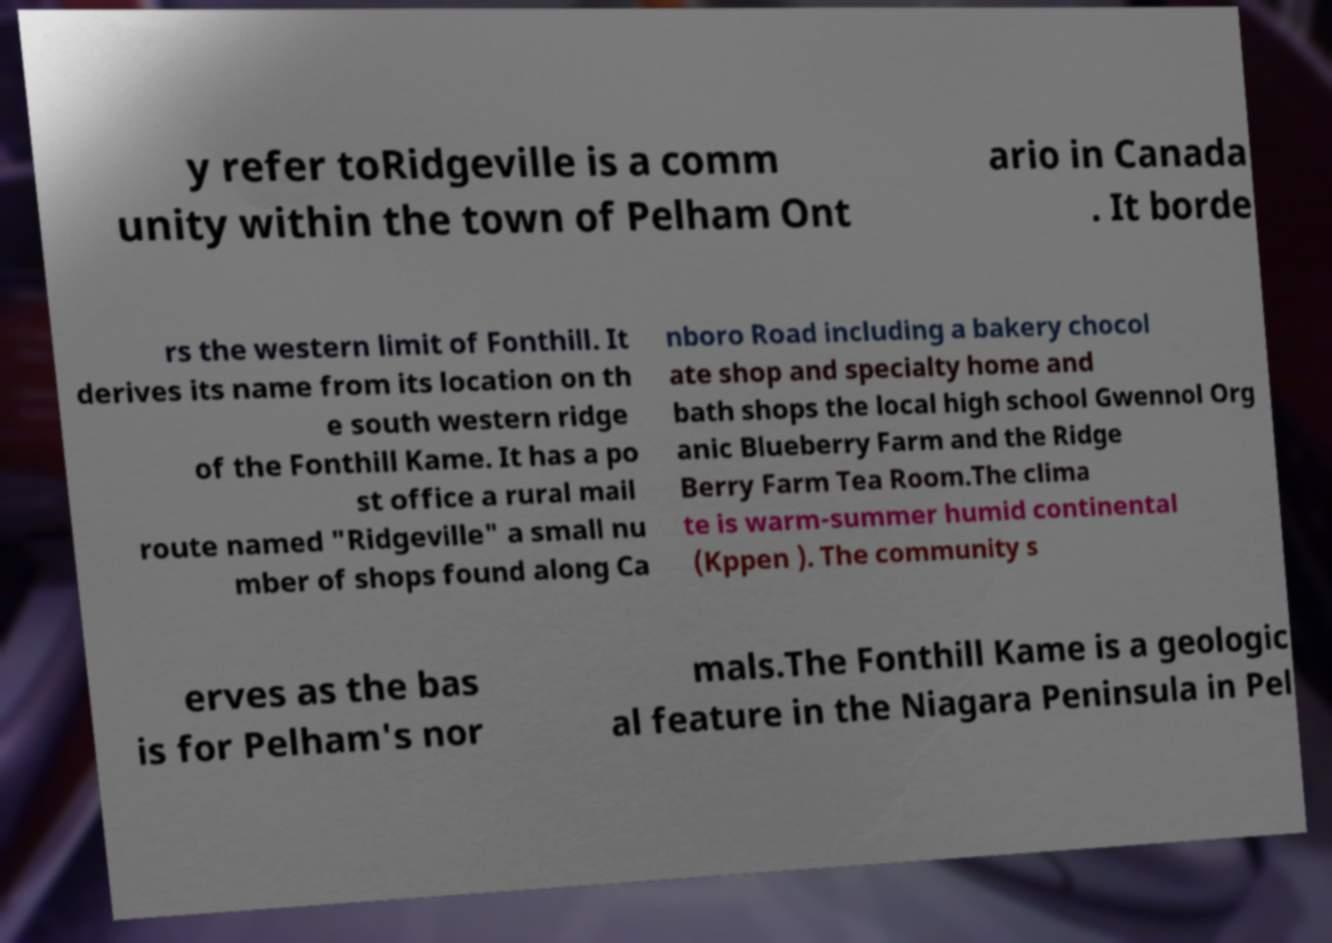Could you assist in decoding the text presented in this image and type it out clearly? y refer toRidgeville is a comm unity within the town of Pelham Ont ario in Canada . It borde rs the western limit of Fonthill. It derives its name from its location on th e south western ridge of the Fonthill Kame. It has a po st office a rural mail route named "Ridgeville" a small nu mber of shops found along Ca nboro Road including a bakery chocol ate shop and specialty home and bath shops the local high school Gwennol Org anic Blueberry Farm and the Ridge Berry Farm Tea Room.The clima te is warm-summer humid continental (Kppen ). The community s erves as the bas is for Pelham's nor mals.The Fonthill Kame is a geologic al feature in the Niagara Peninsula in Pel 